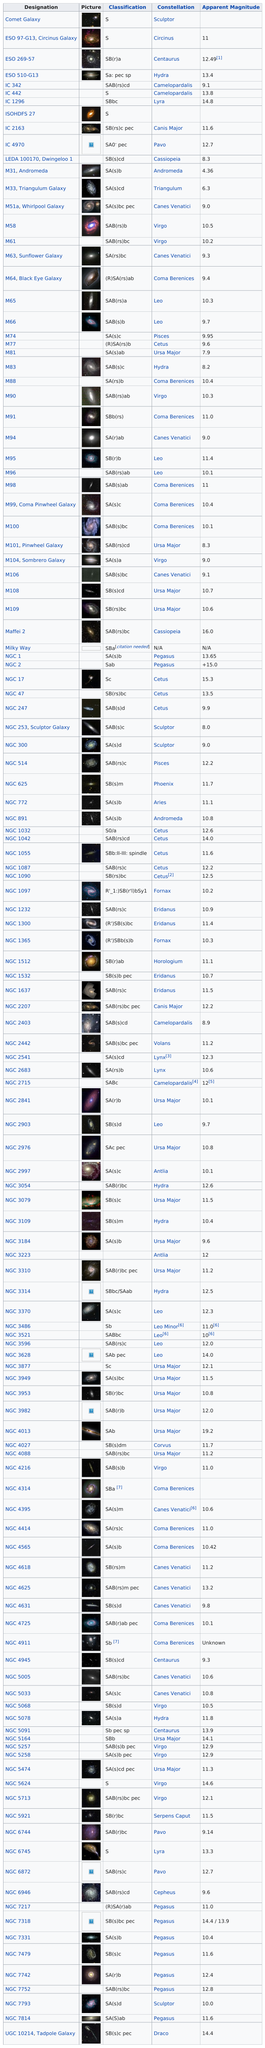Highlight a few significant elements in this photo. The constellation Draco appears last on the table. There are a total of 8 Pegasus constellations depicted on this table. The long name for M63, also known as the Sunflower Galaxy, is NGC 5023. The difference in apparent magnitude between Messier 31 (M31) and Messier 33 (M33) is 1.94. There are four stars that are featured in the constellation Camelopardalis. 